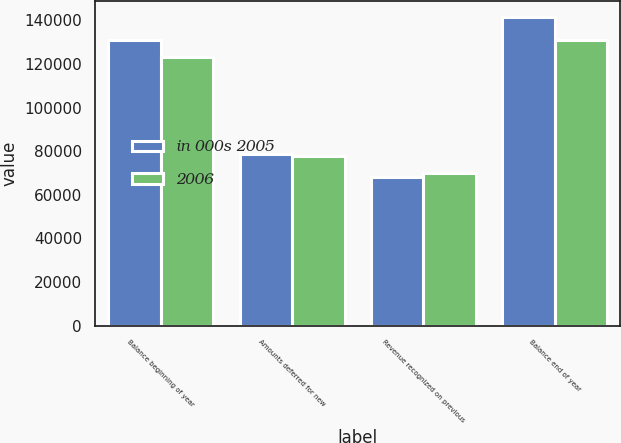<chart> <loc_0><loc_0><loc_500><loc_500><stacked_bar_chart><ecel><fcel>Balance beginning of year<fcel>Amounts deferred for new<fcel>Revenue recognized on previous<fcel>Balance end of year<nl><fcel>in 000s 2005<fcel>130762<fcel>78900<fcel>67978<fcel>141684<nl><fcel>2006<fcel>123048<fcel>77756<fcel>70042<fcel>130762<nl></chart> 